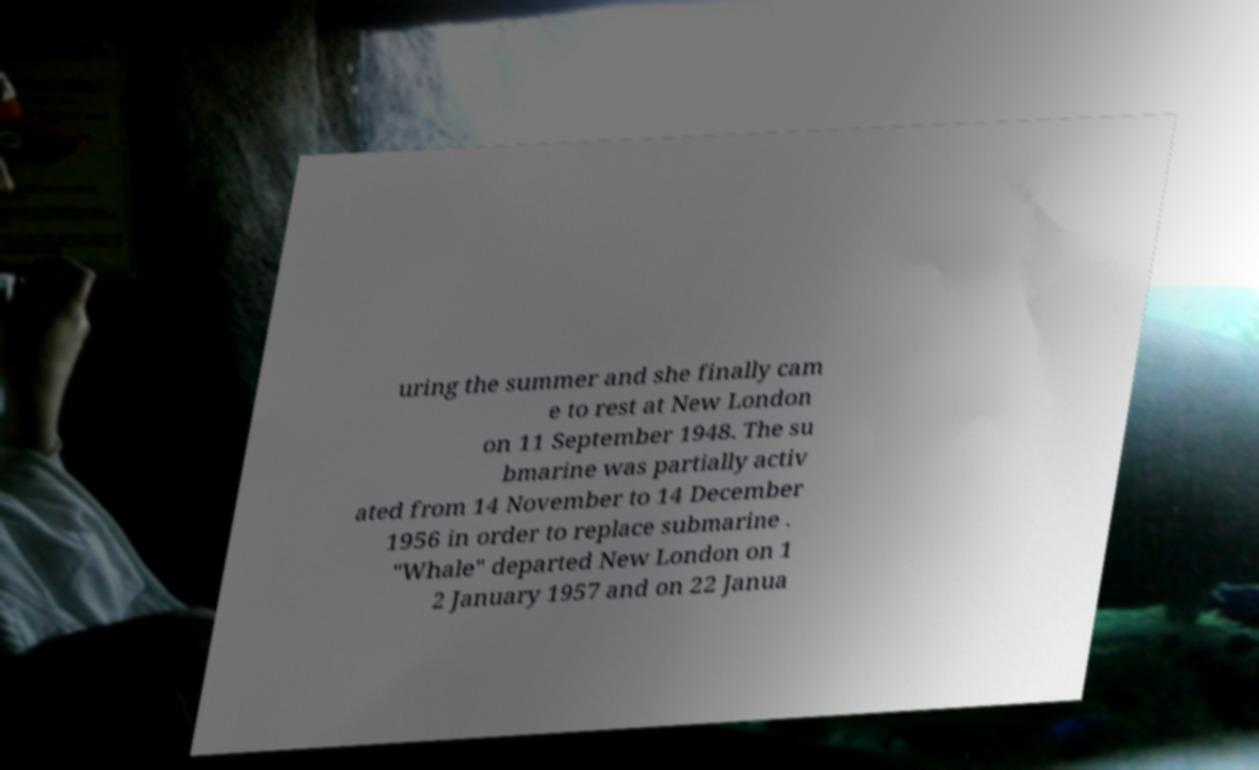Can you accurately transcribe the text from the provided image for me? uring the summer and she finally cam e to rest at New London on 11 September 1948. The su bmarine was partially activ ated from 14 November to 14 December 1956 in order to replace submarine . "Whale" departed New London on 1 2 January 1957 and on 22 Janua 